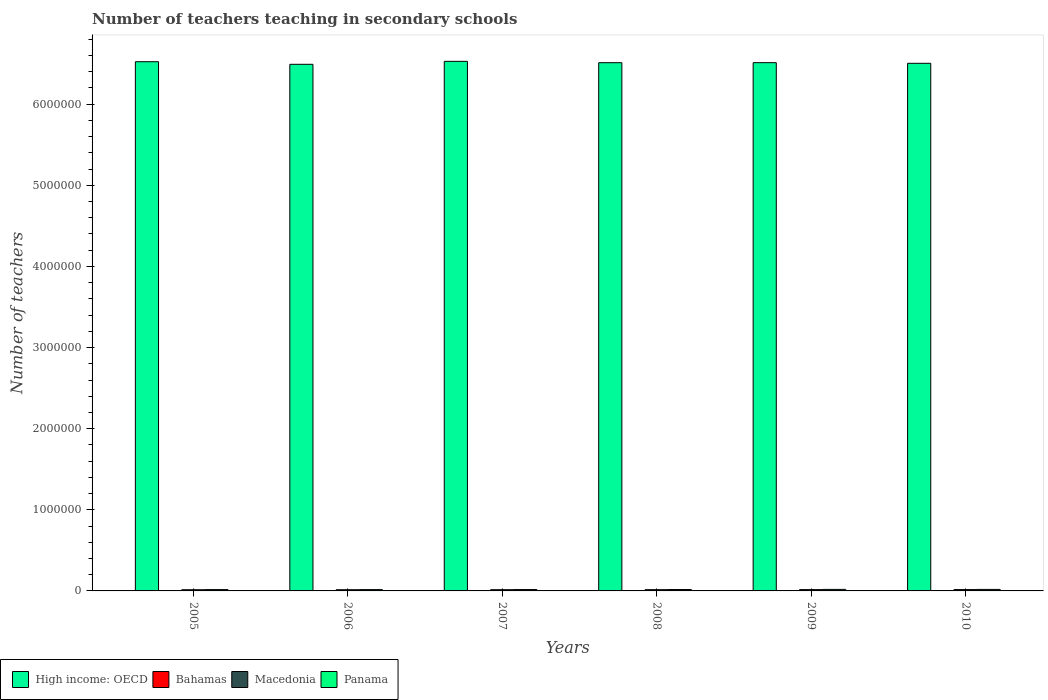How many different coloured bars are there?
Your response must be concise. 4. Are the number of bars on each tick of the X-axis equal?
Give a very brief answer. Yes. How many bars are there on the 5th tick from the right?
Your answer should be compact. 4. What is the label of the 2nd group of bars from the left?
Make the answer very short. 2006. What is the number of teachers teaching in secondary schools in Panama in 2009?
Make the answer very short. 1.88e+04. Across all years, what is the maximum number of teachers teaching in secondary schools in Macedonia?
Offer a very short reply. 1.65e+04. Across all years, what is the minimum number of teachers teaching in secondary schools in Bahamas?
Keep it short and to the point. 2365. What is the total number of teachers teaching in secondary schools in Bahamas in the graph?
Provide a short and direct response. 1.60e+04. What is the difference between the number of teachers teaching in secondary schools in Macedonia in 2007 and that in 2008?
Give a very brief answer. -392. What is the difference between the number of teachers teaching in secondary schools in Bahamas in 2009 and the number of teachers teaching in secondary schools in Panama in 2006?
Your answer should be compact. -1.35e+04. What is the average number of teachers teaching in secondary schools in Bahamas per year?
Your answer should be very brief. 2674.17. In the year 2010, what is the difference between the number of teachers teaching in secondary schools in Bahamas and number of teachers teaching in secondary schools in Panama?
Offer a very short reply. -1.57e+04. In how many years, is the number of teachers teaching in secondary schools in Panama greater than 4400000?
Keep it short and to the point. 0. What is the ratio of the number of teachers teaching in secondary schools in Bahamas in 2006 to that in 2010?
Provide a succinct answer. 0.9. Is the difference between the number of teachers teaching in secondary schools in Bahamas in 2007 and 2009 greater than the difference between the number of teachers teaching in secondary schools in Panama in 2007 and 2009?
Your answer should be very brief. Yes. What is the difference between the highest and the second highest number of teachers teaching in secondary schools in Panama?
Ensure brevity in your answer.  249. What is the difference between the highest and the lowest number of teachers teaching in secondary schools in Bahamas?
Keep it short and to the point. 472. In how many years, is the number of teachers teaching in secondary schools in High income: OECD greater than the average number of teachers teaching in secondary schools in High income: OECD taken over all years?
Your response must be concise. 3. What does the 2nd bar from the left in 2005 represents?
Your answer should be compact. Bahamas. What does the 1st bar from the right in 2009 represents?
Your response must be concise. Panama. Is it the case that in every year, the sum of the number of teachers teaching in secondary schools in Panama and number of teachers teaching in secondary schools in Bahamas is greater than the number of teachers teaching in secondary schools in High income: OECD?
Ensure brevity in your answer.  No. How many bars are there?
Your answer should be very brief. 24. What is the difference between two consecutive major ticks on the Y-axis?
Provide a short and direct response. 1.00e+06. Where does the legend appear in the graph?
Your response must be concise. Bottom left. What is the title of the graph?
Keep it short and to the point. Number of teachers teaching in secondary schools. What is the label or title of the Y-axis?
Make the answer very short. Number of teachers. What is the Number of teachers in High income: OECD in 2005?
Ensure brevity in your answer.  6.52e+06. What is the Number of teachers in Bahamas in 2005?
Offer a terse response. 2365. What is the Number of teachers in Macedonia in 2005?
Make the answer very short. 1.46e+04. What is the Number of teachers of Panama in 2005?
Your answer should be compact. 1.64e+04. What is the Number of teachers in High income: OECD in 2006?
Your answer should be compact. 6.49e+06. What is the Number of teachers of Bahamas in 2006?
Offer a very short reply. 2559. What is the Number of teachers of Macedonia in 2006?
Your answer should be compact. 1.47e+04. What is the Number of teachers of Panama in 2006?
Keep it short and to the point. 1.63e+04. What is the Number of teachers of High income: OECD in 2007?
Provide a short and direct response. 6.53e+06. What is the Number of teachers of Bahamas in 2007?
Ensure brevity in your answer.  2788. What is the Number of teachers in Macedonia in 2007?
Your answer should be compact. 1.52e+04. What is the Number of teachers in Panama in 2007?
Keep it short and to the point. 1.68e+04. What is the Number of teachers in High income: OECD in 2008?
Ensure brevity in your answer.  6.51e+06. What is the Number of teachers in Bahamas in 2008?
Give a very brief answer. 2716. What is the Number of teachers in Macedonia in 2008?
Keep it short and to the point. 1.56e+04. What is the Number of teachers in Panama in 2008?
Make the answer very short. 1.73e+04. What is the Number of teachers in High income: OECD in 2009?
Ensure brevity in your answer.  6.51e+06. What is the Number of teachers in Bahamas in 2009?
Give a very brief answer. 2780. What is the Number of teachers in Macedonia in 2009?
Make the answer very short. 1.61e+04. What is the Number of teachers in Panama in 2009?
Offer a terse response. 1.88e+04. What is the Number of teachers in High income: OECD in 2010?
Provide a succinct answer. 6.50e+06. What is the Number of teachers of Bahamas in 2010?
Offer a terse response. 2837. What is the Number of teachers of Macedonia in 2010?
Your answer should be very brief. 1.65e+04. What is the Number of teachers in Panama in 2010?
Your response must be concise. 1.85e+04. Across all years, what is the maximum Number of teachers of High income: OECD?
Offer a very short reply. 6.53e+06. Across all years, what is the maximum Number of teachers in Bahamas?
Provide a short and direct response. 2837. Across all years, what is the maximum Number of teachers of Macedonia?
Provide a short and direct response. 1.65e+04. Across all years, what is the maximum Number of teachers of Panama?
Your answer should be very brief. 1.88e+04. Across all years, what is the minimum Number of teachers in High income: OECD?
Give a very brief answer. 6.49e+06. Across all years, what is the minimum Number of teachers in Bahamas?
Provide a short and direct response. 2365. Across all years, what is the minimum Number of teachers of Macedonia?
Your answer should be compact. 1.46e+04. Across all years, what is the minimum Number of teachers in Panama?
Offer a terse response. 1.63e+04. What is the total Number of teachers of High income: OECD in the graph?
Provide a short and direct response. 3.91e+07. What is the total Number of teachers in Bahamas in the graph?
Your response must be concise. 1.60e+04. What is the total Number of teachers in Macedonia in the graph?
Keep it short and to the point. 9.27e+04. What is the total Number of teachers of Panama in the graph?
Offer a terse response. 1.04e+05. What is the difference between the Number of teachers of High income: OECD in 2005 and that in 2006?
Your response must be concise. 3.19e+04. What is the difference between the Number of teachers of Bahamas in 2005 and that in 2006?
Ensure brevity in your answer.  -194. What is the difference between the Number of teachers of Macedonia in 2005 and that in 2006?
Provide a short and direct response. -177. What is the difference between the Number of teachers in Panama in 2005 and that in 2006?
Ensure brevity in your answer.  75. What is the difference between the Number of teachers in High income: OECD in 2005 and that in 2007?
Ensure brevity in your answer.  -4464.5. What is the difference between the Number of teachers in Bahamas in 2005 and that in 2007?
Your answer should be compact. -423. What is the difference between the Number of teachers in Macedonia in 2005 and that in 2007?
Provide a short and direct response. -635. What is the difference between the Number of teachers in Panama in 2005 and that in 2007?
Ensure brevity in your answer.  -455. What is the difference between the Number of teachers of High income: OECD in 2005 and that in 2008?
Offer a terse response. 1.22e+04. What is the difference between the Number of teachers of Bahamas in 2005 and that in 2008?
Your answer should be very brief. -351. What is the difference between the Number of teachers in Macedonia in 2005 and that in 2008?
Ensure brevity in your answer.  -1027. What is the difference between the Number of teachers in Panama in 2005 and that in 2008?
Provide a succinct answer. -945. What is the difference between the Number of teachers in High income: OECD in 2005 and that in 2009?
Provide a short and direct response. 1.17e+04. What is the difference between the Number of teachers of Bahamas in 2005 and that in 2009?
Provide a short and direct response. -415. What is the difference between the Number of teachers of Macedonia in 2005 and that in 2009?
Your response must be concise. -1560. What is the difference between the Number of teachers of Panama in 2005 and that in 2009?
Ensure brevity in your answer.  -2358. What is the difference between the Number of teachers of High income: OECD in 2005 and that in 2010?
Ensure brevity in your answer.  1.96e+04. What is the difference between the Number of teachers of Bahamas in 2005 and that in 2010?
Keep it short and to the point. -472. What is the difference between the Number of teachers of Macedonia in 2005 and that in 2010?
Offer a terse response. -1987. What is the difference between the Number of teachers of Panama in 2005 and that in 2010?
Your answer should be compact. -2109. What is the difference between the Number of teachers in High income: OECD in 2006 and that in 2007?
Offer a terse response. -3.64e+04. What is the difference between the Number of teachers in Bahamas in 2006 and that in 2007?
Give a very brief answer. -229. What is the difference between the Number of teachers in Macedonia in 2006 and that in 2007?
Your answer should be compact. -458. What is the difference between the Number of teachers in Panama in 2006 and that in 2007?
Your answer should be very brief. -530. What is the difference between the Number of teachers in High income: OECD in 2006 and that in 2008?
Your answer should be compact. -1.98e+04. What is the difference between the Number of teachers of Bahamas in 2006 and that in 2008?
Keep it short and to the point. -157. What is the difference between the Number of teachers of Macedonia in 2006 and that in 2008?
Provide a succinct answer. -850. What is the difference between the Number of teachers of Panama in 2006 and that in 2008?
Ensure brevity in your answer.  -1020. What is the difference between the Number of teachers of High income: OECD in 2006 and that in 2009?
Offer a very short reply. -2.02e+04. What is the difference between the Number of teachers of Bahamas in 2006 and that in 2009?
Your answer should be compact. -221. What is the difference between the Number of teachers of Macedonia in 2006 and that in 2009?
Provide a short and direct response. -1383. What is the difference between the Number of teachers of Panama in 2006 and that in 2009?
Keep it short and to the point. -2433. What is the difference between the Number of teachers of High income: OECD in 2006 and that in 2010?
Make the answer very short. -1.24e+04. What is the difference between the Number of teachers in Bahamas in 2006 and that in 2010?
Keep it short and to the point. -278. What is the difference between the Number of teachers of Macedonia in 2006 and that in 2010?
Make the answer very short. -1810. What is the difference between the Number of teachers in Panama in 2006 and that in 2010?
Give a very brief answer. -2184. What is the difference between the Number of teachers of High income: OECD in 2007 and that in 2008?
Your answer should be compact. 1.66e+04. What is the difference between the Number of teachers in Bahamas in 2007 and that in 2008?
Offer a terse response. 72. What is the difference between the Number of teachers in Macedonia in 2007 and that in 2008?
Offer a very short reply. -392. What is the difference between the Number of teachers in Panama in 2007 and that in 2008?
Your answer should be very brief. -490. What is the difference between the Number of teachers of High income: OECD in 2007 and that in 2009?
Offer a very short reply. 1.62e+04. What is the difference between the Number of teachers of Bahamas in 2007 and that in 2009?
Offer a very short reply. 8. What is the difference between the Number of teachers in Macedonia in 2007 and that in 2009?
Your response must be concise. -925. What is the difference between the Number of teachers of Panama in 2007 and that in 2009?
Offer a very short reply. -1903. What is the difference between the Number of teachers of High income: OECD in 2007 and that in 2010?
Make the answer very short. 2.40e+04. What is the difference between the Number of teachers in Bahamas in 2007 and that in 2010?
Your answer should be very brief. -49. What is the difference between the Number of teachers of Macedonia in 2007 and that in 2010?
Give a very brief answer. -1352. What is the difference between the Number of teachers of Panama in 2007 and that in 2010?
Make the answer very short. -1654. What is the difference between the Number of teachers of High income: OECD in 2008 and that in 2009?
Offer a terse response. -434.5. What is the difference between the Number of teachers in Bahamas in 2008 and that in 2009?
Your response must be concise. -64. What is the difference between the Number of teachers of Macedonia in 2008 and that in 2009?
Your answer should be very brief. -533. What is the difference between the Number of teachers of Panama in 2008 and that in 2009?
Offer a terse response. -1413. What is the difference between the Number of teachers of High income: OECD in 2008 and that in 2010?
Make the answer very short. 7392. What is the difference between the Number of teachers of Bahamas in 2008 and that in 2010?
Offer a very short reply. -121. What is the difference between the Number of teachers in Macedonia in 2008 and that in 2010?
Your answer should be compact. -960. What is the difference between the Number of teachers in Panama in 2008 and that in 2010?
Provide a succinct answer. -1164. What is the difference between the Number of teachers of High income: OECD in 2009 and that in 2010?
Your answer should be very brief. 7826.5. What is the difference between the Number of teachers in Bahamas in 2009 and that in 2010?
Your answer should be very brief. -57. What is the difference between the Number of teachers in Macedonia in 2009 and that in 2010?
Ensure brevity in your answer.  -427. What is the difference between the Number of teachers of Panama in 2009 and that in 2010?
Give a very brief answer. 249. What is the difference between the Number of teachers of High income: OECD in 2005 and the Number of teachers of Bahamas in 2006?
Ensure brevity in your answer.  6.52e+06. What is the difference between the Number of teachers in High income: OECD in 2005 and the Number of teachers in Macedonia in 2006?
Your answer should be very brief. 6.51e+06. What is the difference between the Number of teachers of High income: OECD in 2005 and the Number of teachers of Panama in 2006?
Ensure brevity in your answer.  6.51e+06. What is the difference between the Number of teachers of Bahamas in 2005 and the Number of teachers of Macedonia in 2006?
Keep it short and to the point. -1.24e+04. What is the difference between the Number of teachers in Bahamas in 2005 and the Number of teachers in Panama in 2006?
Offer a very short reply. -1.40e+04. What is the difference between the Number of teachers in Macedonia in 2005 and the Number of teachers in Panama in 2006?
Ensure brevity in your answer.  -1767. What is the difference between the Number of teachers in High income: OECD in 2005 and the Number of teachers in Bahamas in 2007?
Ensure brevity in your answer.  6.52e+06. What is the difference between the Number of teachers of High income: OECD in 2005 and the Number of teachers of Macedonia in 2007?
Your answer should be compact. 6.51e+06. What is the difference between the Number of teachers in High income: OECD in 2005 and the Number of teachers in Panama in 2007?
Provide a short and direct response. 6.51e+06. What is the difference between the Number of teachers of Bahamas in 2005 and the Number of teachers of Macedonia in 2007?
Keep it short and to the point. -1.28e+04. What is the difference between the Number of teachers of Bahamas in 2005 and the Number of teachers of Panama in 2007?
Your answer should be compact. -1.45e+04. What is the difference between the Number of teachers of Macedonia in 2005 and the Number of teachers of Panama in 2007?
Your answer should be compact. -2297. What is the difference between the Number of teachers in High income: OECD in 2005 and the Number of teachers in Bahamas in 2008?
Your answer should be compact. 6.52e+06. What is the difference between the Number of teachers in High income: OECD in 2005 and the Number of teachers in Macedonia in 2008?
Your answer should be very brief. 6.51e+06. What is the difference between the Number of teachers of High income: OECD in 2005 and the Number of teachers of Panama in 2008?
Provide a short and direct response. 6.51e+06. What is the difference between the Number of teachers of Bahamas in 2005 and the Number of teachers of Macedonia in 2008?
Give a very brief answer. -1.32e+04. What is the difference between the Number of teachers of Bahamas in 2005 and the Number of teachers of Panama in 2008?
Provide a short and direct response. -1.50e+04. What is the difference between the Number of teachers in Macedonia in 2005 and the Number of teachers in Panama in 2008?
Offer a very short reply. -2787. What is the difference between the Number of teachers in High income: OECD in 2005 and the Number of teachers in Bahamas in 2009?
Offer a very short reply. 6.52e+06. What is the difference between the Number of teachers in High income: OECD in 2005 and the Number of teachers in Macedonia in 2009?
Ensure brevity in your answer.  6.51e+06. What is the difference between the Number of teachers of High income: OECD in 2005 and the Number of teachers of Panama in 2009?
Offer a very short reply. 6.51e+06. What is the difference between the Number of teachers of Bahamas in 2005 and the Number of teachers of Macedonia in 2009?
Provide a short and direct response. -1.37e+04. What is the difference between the Number of teachers in Bahamas in 2005 and the Number of teachers in Panama in 2009?
Provide a short and direct response. -1.64e+04. What is the difference between the Number of teachers in Macedonia in 2005 and the Number of teachers in Panama in 2009?
Provide a succinct answer. -4200. What is the difference between the Number of teachers of High income: OECD in 2005 and the Number of teachers of Bahamas in 2010?
Offer a terse response. 6.52e+06. What is the difference between the Number of teachers in High income: OECD in 2005 and the Number of teachers in Macedonia in 2010?
Ensure brevity in your answer.  6.51e+06. What is the difference between the Number of teachers of High income: OECD in 2005 and the Number of teachers of Panama in 2010?
Your answer should be compact. 6.51e+06. What is the difference between the Number of teachers in Bahamas in 2005 and the Number of teachers in Macedonia in 2010?
Ensure brevity in your answer.  -1.42e+04. What is the difference between the Number of teachers of Bahamas in 2005 and the Number of teachers of Panama in 2010?
Provide a short and direct response. -1.61e+04. What is the difference between the Number of teachers of Macedonia in 2005 and the Number of teachers of Panama in 2010?
Offer a very short reply. -3951. What is the difference between the Number of teachers of High income: OECD in 2006 and the Number of teachers of Bahamas in 2007?
Provide a succinct answer. 6.49e+06. What is the difference between the Number of teachers in High income: OECD in 2006 and the Number of teachers in Macedonia in 2007?
Your answer should be compact. 6.48e+06. What is the difference between the Number of teachers of High income: OECD in 2006 and the Number of teachers of Panama in 2007?
Offer a terse response. 6.48e+06. What is the difference between the Number of teachers of Bahamas in 2006 and the Number of teachers of Macedonia in 2007?
Your answer should be very brief. -1.26e+04. What is the difference between the Number of teachers in Bahamas in 2006 and the Number of teachers in Panama in 2007?
Offer a very short reply. -1.43e+04. What is the difference between the Number of teachers in Macedonia in 2006 and the Number of teachers in Panama in 2007?
Provide a short and direct response. -2120. What is the difference between the Number of teachers in High income: OECD in 2006 and the Number of teachers in Bahamas in 2008?
Provide a short and direct response. 6.49e+06. What is the difference between the Number of teachers of High income: OECD in 2006 and the Number of teachers of Macedonia in 2008?
Offer a very short reply. 6.48e+06. What is the difference between the Number of teachers of High income: OECD in 2006 and the Number of teachers of Panama in 2008?
Your answer should be compact. 6.47e+06. What is the difference between the Number of teachers in Bahamas in 2006 and the Number of teachers in Macedonia in 2008?
Offer a very short reply. -1.30e+04. What is the difference between the Number of teachers in Bahamas in 2006 and the Number of teachers in Panama in 2008?
Make the answer very short. -1.48e+04. What is the difference between the Number of teachers of Macedonia in 2006 and the Number of teachers of Panama in 2008?
Your answer should be very brief. -2610. What is the difference between the Number of teachers in High income: OECD in 2006 and the Number of teachers in Bahamas in 2009?
Keep it short and to the point. 6.49e+06. What is the difference between the Number of teachers of High income: OECD in 2006 and the Number of teachers of Macedonia in 2009?
Your answer should be very brief. 6.48e+06. What is the difference between the Number of teachers in High income: OECD in 2006 and the Number of teachers in Panama in 2009?
Make the answer very short. 6.47e+06. What is the difference between the Number of teachers in Bahamas in 2006 and the Number of teachers in Macedonia in 2009?
Provide a short and direct response. -1.36e+04. What is the difference between the Number of teachers of Bahamas in 2006 and the Number of teachers of Panama in 2009?
Your answer should be compact. -1.62e+04. What is the difference between the Number of teachers of Macedonia in 2006 and the Number of teachers of Panama in 2009?
Your answer should be compact. -4023. What is the difference between the Number of teachers in High income: OECD in 2006 and the Number of teachers in Bahamas in 2010?
Your answer should be compact. 6.49e+06. What is the difference between the Number of teachers of High income: OECD in 2006 and the Number of teachers of Macedonia in 2010?
Make the answer very short. 6.48e+06. What is the difference between the Number of teachers in High income: OECD in 2006 and the Number of teachers in Panama in 2010?
Provide a short and direct response. 6.47e+06. What is the difference between the Number of teachers in Bahamas in 2006 and the Number of teachers in Macedonia in 2010?
Give a very brief answer. -1.40e+04. What is the difference between the Number of teachers of Bahamas in 2006 and the Number of teachers of Panama in 2010?
Keep it short and to the point. -1.59e+04. What is the difference between the Number of teachers of Macedonia in 2006 and the Number of teachers of Panama in 2010?
Give a very brief answer. -3774. What is the difference between the Number of teachers of High income: OECD in 2007 and the Number of teachers of Bahamas in 2008?
Give a very brief answer. 6.53e+06. What is the difference between the Number of teachers of High income: OECD in 2007 and the Number of teachers of Macedonia in 2008?
Provide a short and direct response. 6.51e+06. What is the difference between the Number of teachers in High income: OECD in 2007 and the Number of teachers in Panama in 2008?
Your response must be concise. 6.51e+06. What is the difference between the Number of teachers of Bahamas in 2007 and the Number of teachers of Macedonia in 2008?
Ensure brevity in your answer.  -1.28e+04. What is the difference between the Number of teachers of Bahamas in 2007 and the Number of teachers of Panama in 2008?
Make the answer very short. -1.45e+04. What is the difference between the Number of teachers in Macedonia in 2007 and the Number of teachers in Panama in 2008?
Ensure brevity in your answer.  -2152. What is the difference between the Number of teachers in High income: OECD in 2007 and the Number of teachers in Bahamas in 2009?
Provide a short and direct response. 6.53e+06. What is the difference between the Number of teachers in High income: OECD in 2007 and the Number of teachers in Macedonia in 2009?
Your answer should be compact. 6.51e+06. What is the difference between the Number of teachers in High income: OECD in 2007 and the Number of teachers in Panama in 2009?
Offer a very short reply. 6.51e+06. What is the difference between the Number of teachers of Bahamas in 2007 and the Number of teachers of Macedonia in 2009?
Offer a very short reply. -1.33e+04. What is the difference between the Number of teachers in Bahamas in 2007 and the Number of teachers in Panama in 2009?
Provide a succinct answer. -1.60e+04. What is the difference between the Number of teachers in Macedonia in 2007 and the Number of teachers in Panama in 2009?
Give a very brief answer. -3565. What is the difference between the Number of teachers in High income: OECD in 2007 and the Number of teachers in Bahamas in 2010?
Your response must be concise. 6.53e+06. What is the difference between the Number of teachers of High income: OECD in 2007 and the Number of teachers of Macedonia in 2010?
Offer a very short reply. 6.51e+06. What is the difference between the Number of teachers of High income: OECD in 2007 and the Number of teachers of Panama in 2010?
Your response must be concise. 6.51e+06. What is the difference between the Number of teachers of Bahamas in 2007 and the Number of teachers of Macedonia in 2010?
Offer a very short reply. -1.37e+04. What is the difference between the Number of teachers in Bahamas in 2007 and the Number of teachers in Panama in 2010?
Your answer should be very brief. -1.57e+04. What is the difference between the Number of teachers in Macedonia in 2007 and the Number of teachers in Panama in 2010?
Offer a terse response. -3316. What is the difference between the Number of teachers of High income: OECD in 2008 and the Number of teachers of Bahamas in 2009?
Your answer should be compact. 6.51e+06. What is the difference between the Number of teachers in High income: OECD in 2008 and the Number of teachers in Macedonia in 2009?
Your answer should be very brief. 6.50e+06. What is the difference between the Number of teachers of High income: OECD in 2008 and the Number of teachers of Panama in 2009?
Offer a very short reply. 6.49e+06. What is the difference between the Number of teachers in Bahamas in 2008 and the Number of teachers in Macedonia in 2009?
Offer a terse response. -1.34e+04. What is the difference between the Number of teachers of Bahamas in 2008 and the Number of teachers of Panama in 2009?
Ensure brevity in your answer.  -1.60e+04. What is the difference between the Number of teachers in Macedonia in 2008 and the Number of teachers in Panama in 2009?
Offer a very short reply. -3173. What is the difference between the Number of teachers in High income: OECD in 2008 and the Number of teachers in Bahamas in 2010?
Provide a succinct answer. 6.51e+06. What is the difference between the Number of teachers in High income: OECD in 2008 and the Number of teachers in Macedonia in 2010?
Your answer should be very brief. 6.50e+06. What is the difference between the Number of teachers of High income: OECD in 2008 and the Number of teachers of Panama in 2010?
Your answer should be compact. 6.49e+06. What is the difference between the Number of teachers of Bahamas in 2008 and the Number of teachers of Macedonia in 2010?
Ensure brevity in your answer.  -1.38e+04. What is the difference between the Number of teachers in Bahamas in 2008 and the Number of teachers in Panama in 2010?
Give a very brief answer. -1.58e+04. What is the difference between the Number of teachers in Macedonia in 2008 and the Number of teachers in Panama in 2010?
Offer a terse response. -2924. What is the difference between the Number of teachers of High income: OECD in 2009 and the Number of teachers of Bahamas in 2010?
Give a very brief answer. 6.51e+06. What is the difference between the Number of teachers in High income: OECD in 2009 and the Number of teachers in Macedonia in 2010?
Provide a short and direct response. 6.50e+06. What is the difference between the Number of teachers in High income: OECD in 2009 and the Number of teachers in Panama in 2010?
Offer a very short reply. 6.49e+06. What is the difference between the Number of teachers of Bahamas in 2009 and the Number of teachers of Macedonia in 2010?
Offer a terse response. -1.38e+04. What is the difference between the Number of teachers in Bahamas in 2009 and the Number of teachers in Panama in 2010?
Ensure brevity in your answer.  -1.57e+04. What is the difference between the Number of teachers in Macedonia in 2009 and the Number of teachers in Panama in 2010?
Offer a very short reply. -2391. What is the average Number of teachers in High income: OECD per year?
Make the answer very short. 6.51e+06. What is the average Number of teachers in Bahamas per year?
Your answer should be compact. 2674.17. What is the average Number of teachers in Macedonia per year?
Offer a very short reply. 1.54e+04. What is the average Number of teachers in Panama per year?
Make the answer very short. 1.74e+04. In the year 2005, what is the difference between the Number of teachers of High income: OECD and Number of teachers of Bahamas?
Provide a short and direct response. 6.52e+06. In the year 2005, what is the difference between the Number of teachers of High income: OECD and Number of teachers of Macedonia?
Give a very brief answer. 6.51e+06. In the year 2005, what is the difference between the Number of teachers of High income: OECD and Number of teachers of Panama?
Give a very brief answer. 6.51e+06. In the year 2005, what is the difference between the Number of teachers of Bahamas and Number of teachers of Macedonia?
Provide a short and direct response. -1.22e+04. In the year 2005, what is the difference between the Number of teachers of Bahamas and Number of teachers of Panama?
Give a very brief answer. -1.40e+04. In the year 2005, what is the difference between the Number of teachers of Macedonia and Number of teachers of Panama?
Give a very brief answer. -1842. In the year 2006, what is the difference between the Number of teachers in High income: OECD and Number of teachers in Bahamas?
Offer a very short reply. 6.49e+06. In the year 2006, what is the difference between the Number of teachers in High income: OECD and Number of teachers in Macedonia?
Offer a terse response. 6.48e+06. In the year 2006, what is the difference between the Number of teachers of High income: OECD and Number of teachers of Panama?
Your answer should be compact. 6.48e+06. In the year 2006, what is the difference between the Number of teachers in Bahamas and Number of teachers in Macedonia?
Offer a terse response. -1.22e+04. In the year 2006, what is the difference between the Number of teachers in Bahamas and Number of teachers in Panama?
Ensure brevity in your answer.  -1.38e+04. In the year 2006, what is the difference between the Number of teachers of Macedonia and Number of teachers of Panama?
Your response must be concise. -1590. In the year 2007, what is the difference between the Number of teachers in High income: OECD and Number of teachers in Bahamas?
Provide a succinct answer. 6.53e+06. In the year 2007, what is the difference between the Number of teachers in High income: OECD and Number of teachers in Macedonia?
Offer a very short reply. 6.51e+06. In the year 2007, what is the difference between the Number of teachers of High income: OECD and Number of teachers of Panama?
Ensure brevity in your answer.  6.51e+06. In the year 2007, what is the difference between the Number of teachers of Bahamas and Number of teachers of Macedonia?
Provide a short and direct response. -1.24e+04. In the year 2007, what is the difference between the Number of teachers in Bahamas and Number of teachers in Panama?
Offer a very short reply. -1.41e+04. In the year 2007, what is the difference between the Number of teachers in Macedonia and Number of teachers in Panama?
Your answer should be very brief. -1662. In the year 2008, what is the difference between the Number of teachers of High income: OECD and Number of teachers of Bahamas?
Offer a very short reply. 6.51e+06. In the year 2008, what is the difference between the Number of teachers of High income: OECD and Number of teachers of Macedonia?
Provide a short and direct response. 6.50e+06. In the year 2008, what is the difference between the Number of teachers in High income: OECD and Number of teachers in Panama?
Your answer should be very brief. 6.49e+06. In the year 2008, what is the difference between the Number of teachers in Bahamas and Number of teachers in Macedonia?
Provide a short and direct response. -1.29e+04. In the year 2008, what is the difference between the Number of teachers in Bahamas and Number of teachers in Panama?
Your answer should be compact. -1.46e+04. In the year 2008, what is the difference between the Number of teachers of Macedonia and Number of teachers of Panama?
Provide a succinct answer. -1760. In the year 2009, what is the difference between the Number of teachers in High income: OECD and Number of teachers in Bahamas?
Make the answer very short. 6.51e+06. In the year 2009, what is the difference between the Number of teachers in High income: OECD and Number of teachers in Macedonia?
Make the answer very short. 6.50e+06. In the year 2009, what is the difference between the Number of teachers in High income: OECD and Number of teachers in Panama?
Your answer should be compact. 6.49e+06. In the year 2009, what is the difference between the Number of teachers in Bahamas and Number of teachers in Macedonia?
Keep it short and to the point. -1.33e+04. In the year 2009, what is the difference between the Number of teachers in Bahamas and Number of teachers in Panama?
Offer a very short reply. -1.60e+04. In the year 2009, what is the difference between the Number of teachers of Macedonia and Number of teachers of Panama?
Provide a succinct answer. -2640. In the year 2010, what is the difference between the Number of teachers in High income: OECD and Number of teachers in Bahamas?
Your response must be concise. 6.50e+06. In the year 2010, what is the difference between the Number of teachers of High income: OECD and Number of teachers of Macedonia?
Give a very brief answer. 6.49e+06. In the year 2010, what is the difference between the Number of teachers of High income: OECD and Number of teachers of Panama?
Ensure brevity in your answer.  6.49e+06. In the year 2010, what is the difference between the Number of teachers of Bahamas and Number of teachers of Macedonia?
Provide a short and direct response. -1.37e+04. In the year 2010, what is the difference between the Number of teachers of Bahamas and Number of teachers of Panama?
Ensure brevity in your answer.  -1.57e+04. In the year 2010, what is the difference between the Number of teachers in Macedonia and Number of teachers in Panama?
Provide a succinct answer. -1964. What is the ratio of the Number of teachers of High income: OECD in 2005 to that in 2006?
Your response must be concise. 1. What is the ratio of the Number of teachers in Bahamas in 2005 to that in 2006?
Provide a short and direct response. 0.92. What is the ratio of the Number of teachers in Panama in 2005 to that in 2006?
Your answer should be very brief. 1. What is the ratio of the Number of teachers of High income: OECD in 2005 to that in 2007?
Your response must be concise. 1. What is the ratio of the Number of teachers in Bahamas in 2005 to that in 2007?
Keep it short and to the point. 0.85. What is the ratio of the Number of teachers of Macedonia in 2005 to that in 2007?
Give a very brief answer. 0.96. What is the ratio of the Number of teachers in Bahamas in 2005 to that in 2008?
Keep it short and to the point. 0.87. What is the ratio of the Number of teachers of Macedonia in 2005 to that in 2008?
Offer a terse response. 0.93. What is the ratio of the Number of teachers in Panama in 2005 to that in 2008?
Your answer should be compact. 0.95. What is the ratio of the Number of teachers of Bahamas in 2005 to that in 2009?
Your response must be concise. 0.85. What is the ratio of the Number of teachers in Macedonia in 2005 to that in 2009?
Your answer should be very brief. 0.9. What is the ratio of the Number of teachers in Panama in 2005 to that in 2009?
Provide a succinct answer. 0.87. What is the ratio of the Number of teachers of Bahamas in 2005 to that in 2010?
Provide a short and direct response. 0.83. What is the ratio of the Number of teachers of Macedonia in 2005 to that in 2010?
Make the answer very short. 0.88. What is the ratio of the Number of teachers of Panama in 2005 to that in 2010?
Make the answer very short. 0.89. What is the ratio of the Number of teachers in Bahamas in 2006 to that in 2007?
Provide a succinct answer. 0.92. What is the ratio of the Number of teachers of Macedonia in 2006 to that in 2007?
Keep it short and to the point. 0.97. What is the ratio of the Number of teachers of Panama in 2006 to that in 2007?
Offer a very short reply. 0.97. What is the ratio of the Number of teachers in Bahamas in 2006 to that in 2008?
Keep it short and to the point. 0.94. What is the ratio of the Number of teachers of Macedonia in 2006 to that in 2008?
Ensure brevity in your answer.  0.95. What is the ratio of the Number of teachers in Panama in 2006 to that in 2008?
Ensure brevity in your answer.  0.94. What is the ratio of the Number of teachers in High income: OECD in 2006 to that in 2009?
Offer a very short reply. 1. What is the ratio of the Number of teachers in Bahamas in 2006 to that in 2009?
Ensure brevity in your answer.  0.92. What is the ratio of the Number of teachers of Macedonia in 2006 to that in 2009?
Your answer should be compact. 0.91. What is the ratio of the Number of teachers of Panama in 2006 to that in 2009?
Offer a terse response. 0.87. What is the ratio of the Number of teachers of Bahamas in 2006 to that in 2010?
Give a very brief answer. 0.9. What is the ratio of the Number of teachers of Macedonia in 2006 to that in 2010?
Your answer should be very brief. 0.89. What is the ratio of the Number of teachers of Panama in 2006 to that in 2010?
Provide a succinct answer. 0.88. What is the ratio of the Number of teachers of High income: OECD in 2007 to that in 2008?
Your answer should be very brief. 1. What is the ratio of the Number of teachers of Bahamas in 2007 to that in 2008?
Offer a terse response. 1.03. What is the ratio of the Number of teachers of Macedonia in 2007 to that in 2008?
Give a very brief answer. 0.97. What is the ratio of the Number of teachers of Panama in 2007 to that in 2008?
Ensure brevity in your answer.  0.97. What is the ratio of the Number of teachers of Bahamas in 2007 to that in 2009?
Your response must be concise. 1. What is the ratio of the Number of teachers of Macedonia in 2007 to that in 2009?
Give a very brief answer. 0.94. What is the ratio of the Number of teachers in Panama in 2007 to that in 2009?
Offer a very short reply. 0.9. What is the ratio of the Number of teachers of High income: OECD in 2007 to that in 2010?
Offer a terse response. 1. What is the ratio of the Number of teachers in Bahamas in 2007 to that in 2010?
Ensure brevity in your answer.  0.98. What is the ratio of the Number of teachers in Macedonia in 2007 to that in 2010?
Your response must be concise. 0.92. What is the ratio of the Number of teachers of Panama in 2007 to that in 2010?
Your answer should be very brief. 0.91. What is the ratio of the Number of teachers in Macedonia in 2008 to that in 2009?
Your answer should be very brief. 0.97. What is the ratio of the Number of teachers of Panama in 2008 to that in 2009?
Give a very brief answer. 0.92. What is the ratio of the Number of teachers of High income: OECD in 2008 to that in 2010?
Offer a very short reply. 1. What is the ratio of the Number of teachers of Bahamas in 2008 to that in 2010?
Make the answer very short. 0.96. What is the ratio of the Number of teachers in Macedonia in 2008 to that in 2010?
Offer a very short reply. 0.94. What is the ratio of the Number of teachers of Panama in 2008 to that in 2010?
Your answer should be very brief. 0.94. What is the ratio of the Number of teachers of Bahamas in 2009 to that in 2010?
Your answer should be compact. 0.98. What is the ratio of the Number of teachers in Macedonia in 2009 to that in 2010?
Provide a succinct answer. 0.97. What is the ratio of the Number of teachers in Panama in 2009 to that in 2010?
Your answer should be compact. 1.01. What is the difference between the highest and the second highest Number of teachers in High income: OECD?
Ensure brevity in your answer.  4464.5. What is the difference between the highest and the second highest Number of teachers in Macedonia?
Give a very brief answer. 427. What is the difference between the highest and the second highest Number of teachers of Panama?
Your response must be concise. 249. What is the difference between the highest and the lowest Number of teachers in High income: OECD?
Your response must be concise. 3.64e+04. What is the difference between the highest and the lowest Number of teachers of Bahamas?
Give a very brief answer. 472. What is the difference between the highest and the lowest Number of teachers of Macedonia?
Ensure brevity in your answer.  1987. What is the difference between the highest and the lowest Number of teachers of Panama?
Your response must be concise. 2433. 